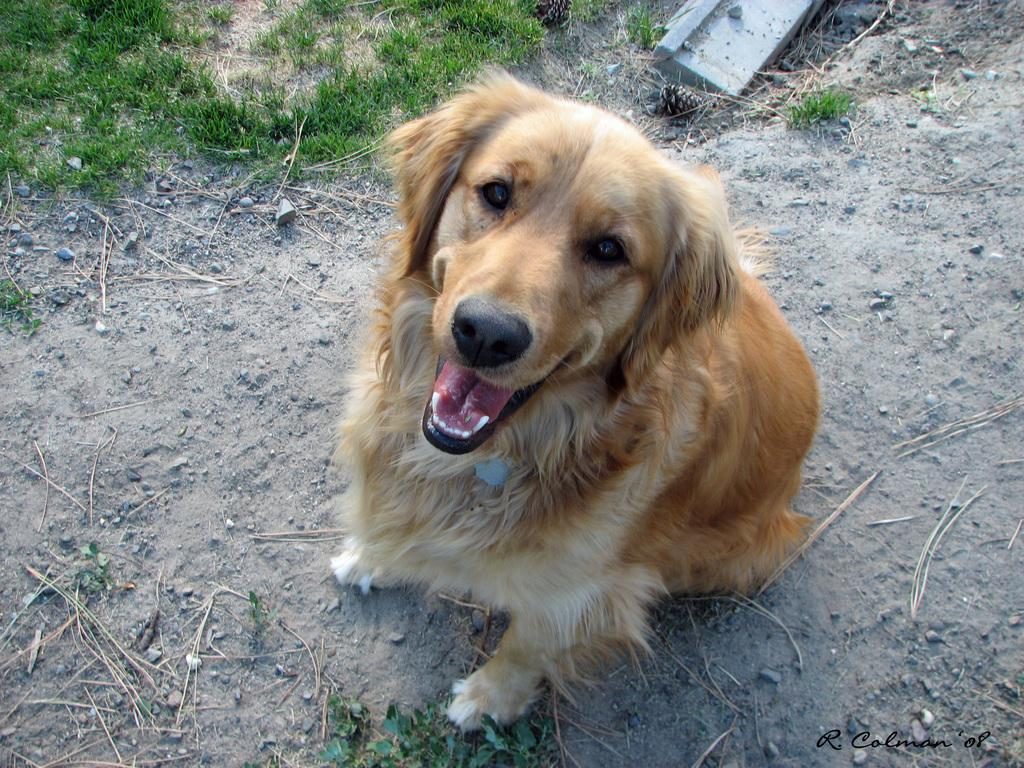What type of animal can be seen on the surface in the image? There is a dog on the surface in the image. What type of vegetation is visible in the image? There is grass visible in the image. What other natural elements can be seen in the image? Leaves and stones are visible in the image. Is there any text present in the image? Yes, there is text in the bottom right of the image. Where is the plastic lunchroom located in the image? There is no plastic lunchroom present in the image. What type of harbor can be seen in the image? There is no harbor present in the image. 